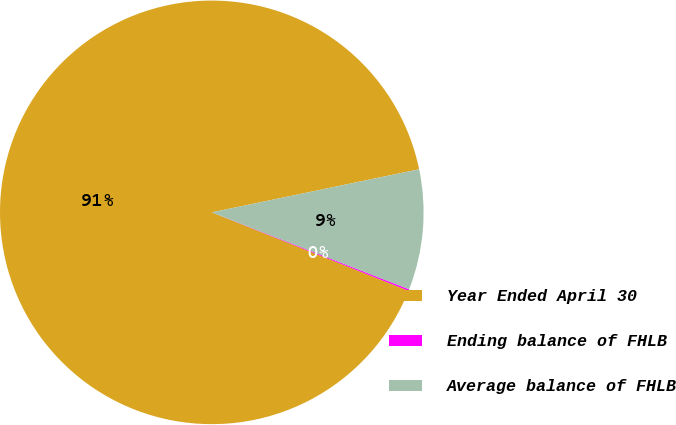Convert chart. <chart><loc_0><loc_0><loc_500><loc_500><pie_chart><fcel>Year Ended April 30<fcel>Ending balance of FHLB<fcel>Average balance of FHLB<nl><fcel>90.7%<fcel>0.12%<fcel>9.18%<nl></chart> 